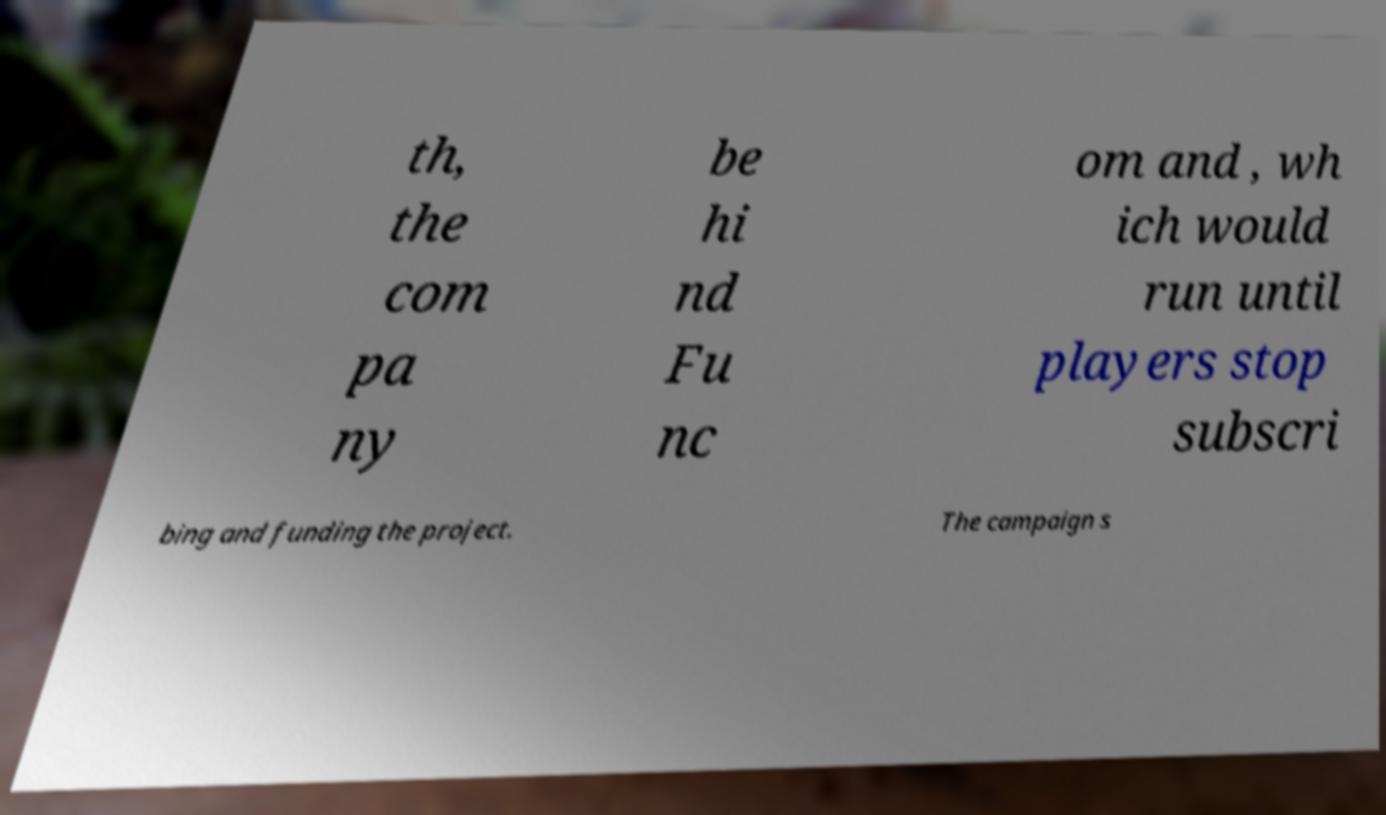Please read and relay the text visible in this image. What does it say? th, the com pa ny be hi nd Fu nc om and , wh ich would run until players stop subscri bing and funding the project. The campaign s 